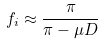Convert formula to latex. <formula><loc_0><loc_0><loc_500><loc_500>f _ { i } \approx \frac { \pi } { \pi - \mu D }</formula> 